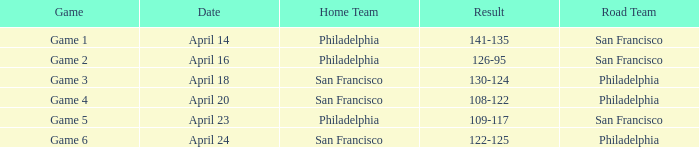Which games featured philadelphia as the host team? Game 1, Game 2, Game 5. 